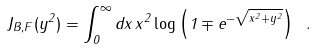Convert formula to latex. <formula><loc_0><loc_0><loc_500><loc_500>J _ { B , F } ( y ^ { 2 } ) = \int _ { 0 } ^ { \infty } d x \, x ^ { 2 } \log \left ( 1 \mp e ^ { - \sqrt { x ^ { 2 } + y ^ { 2 } } } \right ) \ .</formula> 